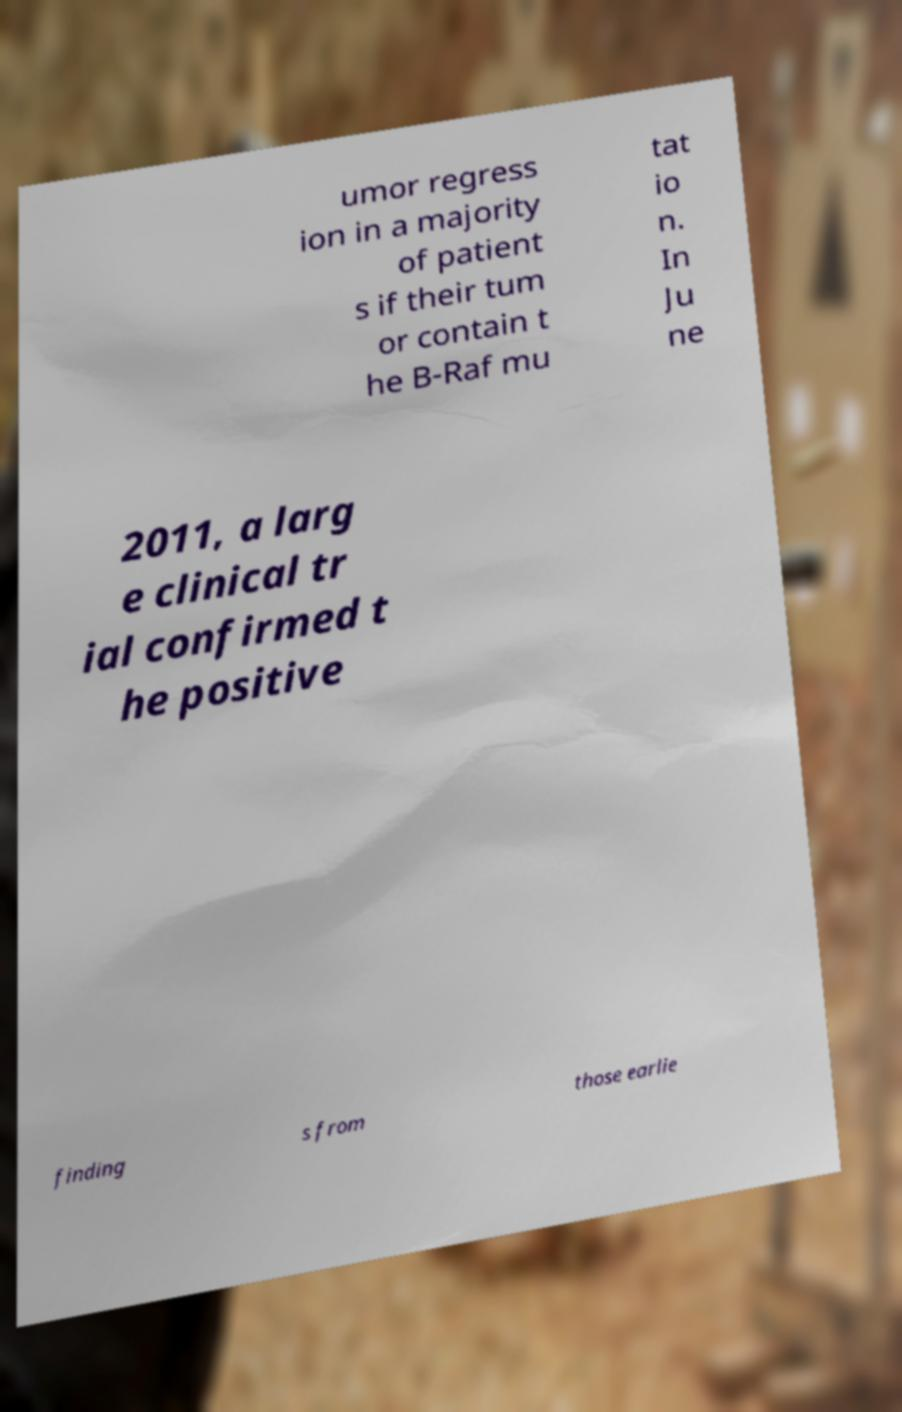For documentation purposes, I need the text within this image transcribed. Could you provide that? umor regress ion in a majority of patient s if their tum or contain t he B-Raf mu tat io n. In Ju ne 2011, a larg e clinical tr ial confirmed t he positive finding s from those earlie 